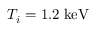Convert formula to latex. <formula><loc_0><loc_0><loc_500><loc_500>T _ { i } = 1 . 2 \, k e V</formula> 